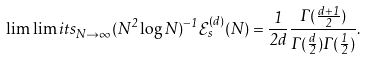Convert formula to latex. <formula><loc_0><loc_0><loc_500><loc_500>\lim \lim i t s _ { N \rightarrow \infty } ( N ^ { 2 } \log N ) ^ { - 1 } \mathcal { E } _ { s } ^ { ( d ) } ( N ) = \frac { 1 } { 2 d } \frac { \Gamma ( \frac { d + 1 } { 2 } ) } { \Gamma ( \frac { d } { 2 } ) \Gamma ( \frac { 1 } { 2 } ) } .</formula> 